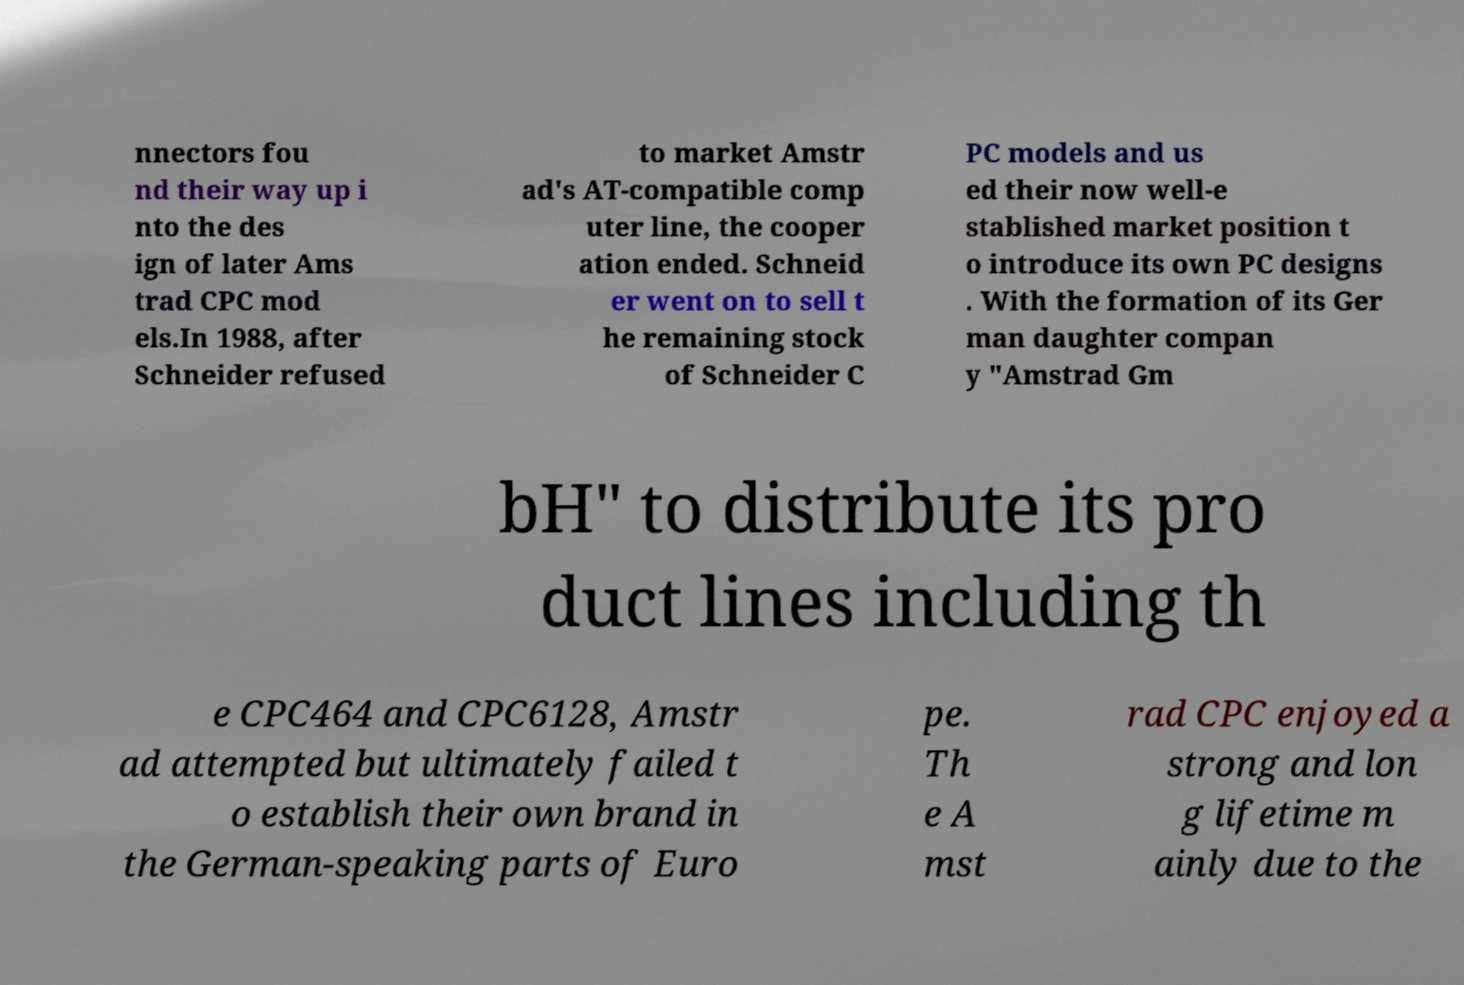Please read and relay the text visible in this image. What does it say? nnectors fou nd their way up i nto the des ign of later Ams trad CPC mod els.In 1988, after Schneider refused to market Amstr ad's AT-compatible comp uter line, the cooper ation ended. Schneid er went on to sell t he remaining stock of Schneider C PC models and us ed their now well-e stablished market position t o introduce its own PC designs . With the formation of its Ger man daughter compan y "Amstrad Gm bH" to distribute its pro duct lines including th e CPC464 and CPC6128, Amstr ad attempted but ultimately failed t o establish their own brand in the German-speaking parts of Euro pe. Th e A mst rad CPC enjoyed a strong and lon g lifetime m ainly due to the 